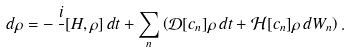<formula> <loc_0><loc_0><loc_500><loc_500>d \rho = - \, \frac { i } { } [ H , \rho ] \, d t + \sum _ { n } \left ( \mathcal { D } [ c _ { n } ] \rho \, d t + \mathcal { H } [ c _ { n } ] \rho \, d W _ { n } \right ) .</formula> 